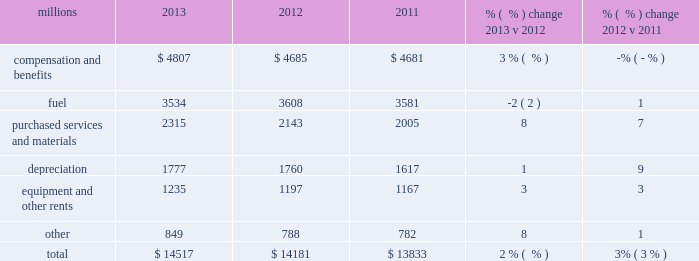Operating expenses millions 2013 2012 2011 % (  % ) change 2013 v 2012 % (  % ) change 2012 v 2011 .
Operating expenses increased $ 336 million in 2013 versus 2012 .
Wage and benefit inflation , new logistics management fees and container costs for our automotive business , locomotive overhauls , property taxes and repairs on jointly owned property contributed to higher expenses during the year .
Lower fuel prices partially offset the cost increases .
Operating expenses increased $ 348 million in 2012 versus 2011 .
Depreciation , wage and benefit inflation , higher fuel prices and volume- related trucking services purchased by our logistics subsidiaries , contributed to higher expenses during the year .
Efficiency gains , volume related fuel savings ( 2% ( 2 % ) fewer gallons of fuel consumed ) and $ 38 million of weather related expenses in 2011 , which favorably affects the comparison , partially offset the cost increase .
Compensation and benefits 2013 compensation and benefits include wages , payroll taxes , health and welfare costs , pension costs , other postretirement benefits , and incentive costs .
General wages and benefits inflation , higher work force levels and increased pension and other postretirement benefits drove the increases in 2013 versus 2012 .
The impact of ongoing productivity initiatives partially offset these increases .
Expenses in 2012 were essentially flat versus 2011 as operational improvements and cost reductions offset general wage and benefit inflation and higher pension and other postretirement benefits .
In addition , weather related costs increased these expenses in 2011 .
Fuel 2013 fuel includes locomotive fuel and gasoline for highway and non-highway vehicles and heavy equipment .
Lower locomotive diesel fuel prices , which averaged $ 3.15 per gallon ( including taxes and transportation costs ) in 2013 , compared to $ 3.22 in 2012 , decreased expenses by $ 75 million .
Volume , as measured by gross ton-miles , decreased 1% ( 1 % ) while the fuel consumption rate , computed as gallons of fuel consumed divided by gross ton-miles , increased 2% ( 2 % ) compared to 2012 .
Declines in heavier , more fuel-efficient coal shipments drove the variances in gross-ton-miles and the fuel consumption rate .
Higher locomotive diesel fuel prices , which averaged $ 3.22 per gallon ( including taxes and transportation costs ) in 2012 , compared to $ 3.12 in 2011 , increased expenses by $ 105 million .
Volume , as measured by gross ton-miles , decreased 2% ( 2 % ) in 2012 versus 2011 , driving expense down .
The fuel consumption rate was flat year-over-year .
Purchased services and materials 2013 expense for purchased services and materials includes the costs of services purchased from outside contractors and other service providers ( including equipment maintenance and contract expenses incurred by our subsidiaries for external transportation services ) ; materials used to maintain the railroad 2019s lines , structures , and equipment ; costs of operating facilities jointly used by uprr and other railroads ; transportation and lodging for train crew employees ; trucking and contracting costs for intermodal containers ; leased automobile maintenance expenses ; and tools and 2013 operating expenses .
What percentage of total operating expenses was fuel in 2012? 
Computations: (3608 / 14181)
Answer: 0.25442. 